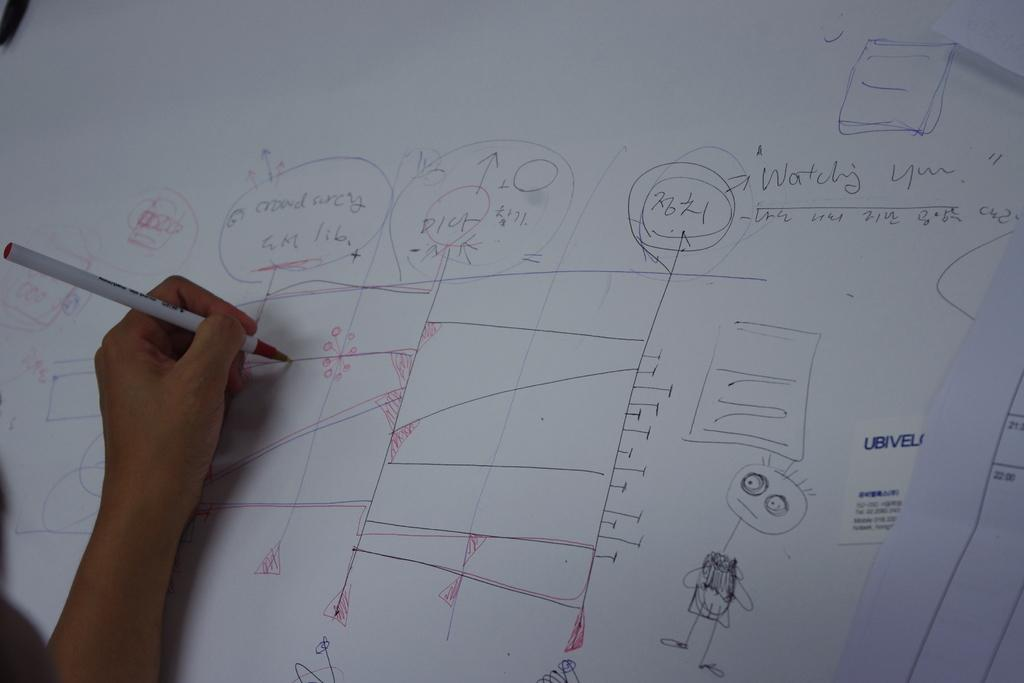What is being held in the person's hand in the image? There is a person's hand holding a pen in the image. What is the main object in the image besides the hand? There is a white color chart in the image. What can be found on the color chart? There is written text and drawings on the chart. How many brothers are depicted in the image? There are no brothers depicted in the image; it features a hand holding a pen and a color chart. What type of pencil is being used to draw on the chart? There is no pencil present in the image; the person is holding a pen. 